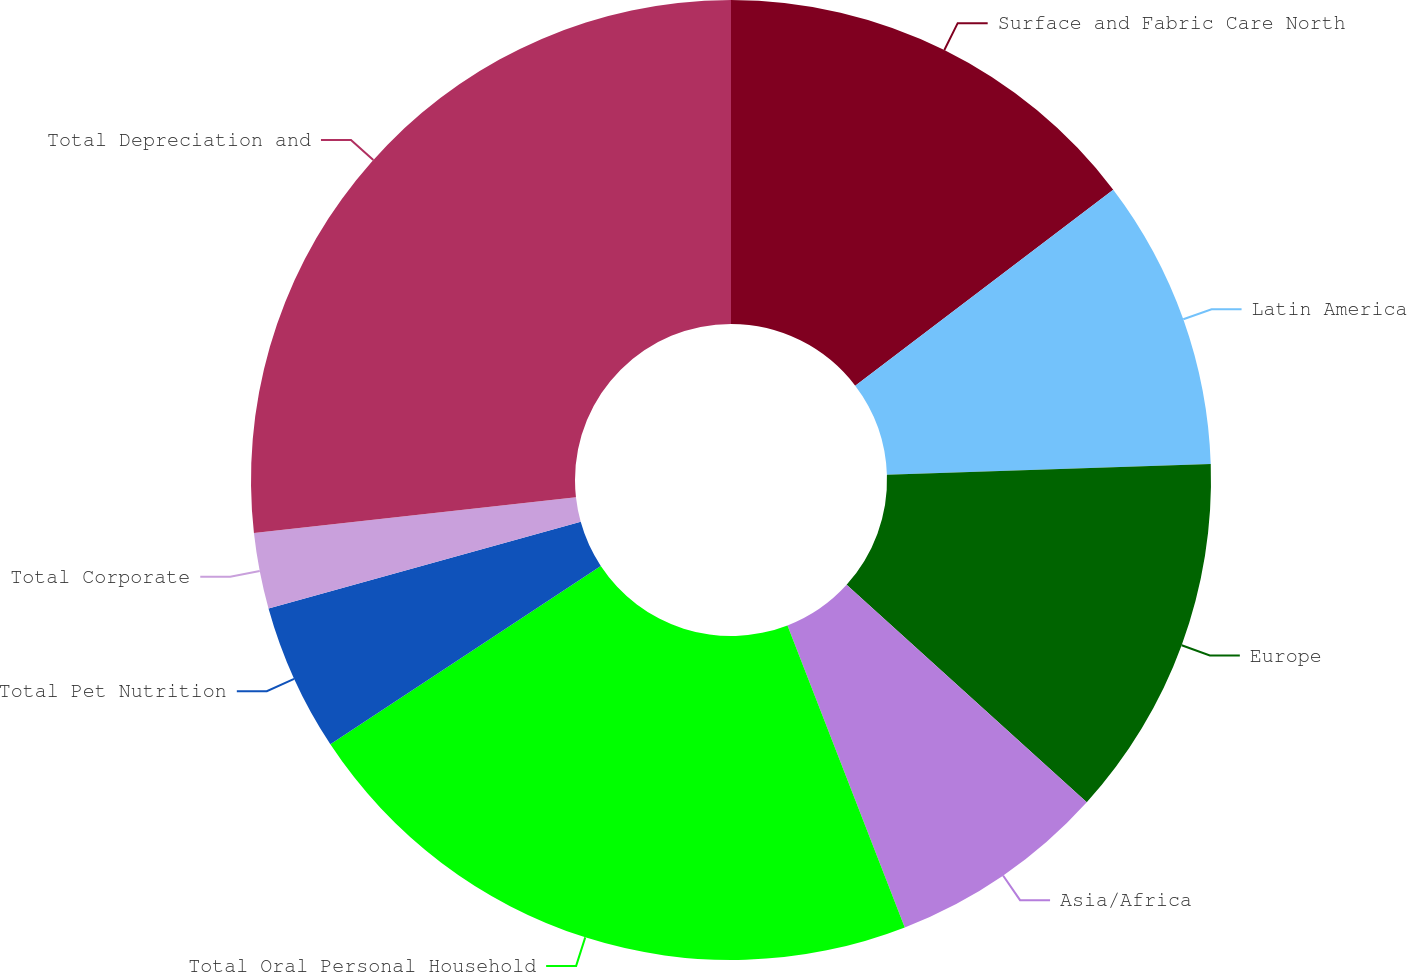Convert chart. <chart><loc_0><loc_0><loc_500><loc_500><pie_chart><fcel>Surface and Fabric Care North<fcel>Latin America<fcel>Europe<fcel>Asia/Africa<fcel>Total Oral Personal Household<fcel>Total Pet Nutrition<fcel>Total Corporate<fcel>Total Depreciation and<nl><fcel>14.66%<fcel>9.81%<fcel>12.24%<fcel>7.39%<fcel>21.61%<fcel>4.97%<fcel>2.55%<fcel>26.76%<nl></chart> 